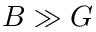Convert formula to latex. <formula><loc_0><loc_0><loc_500><loc_500>B \gg G</formula> 